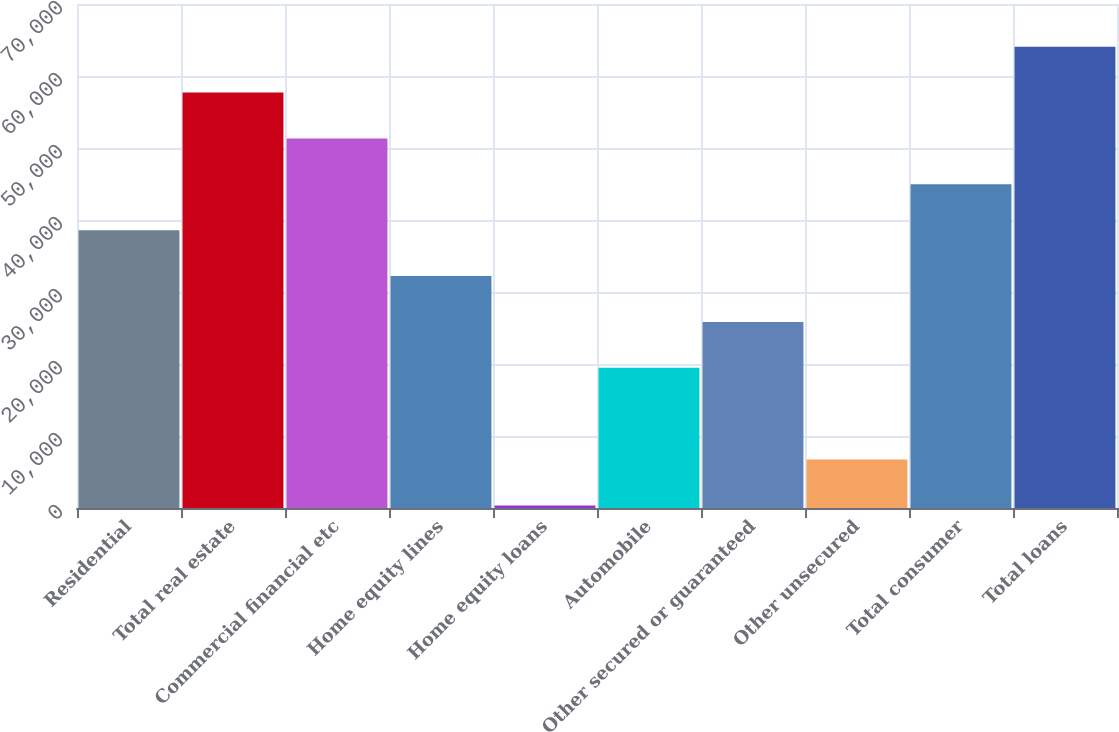<chart> <loc_0><loc_0><loc_500><loc_500><bar_chart><fcel>Residential<fcel>Total real estate<fcel>Commercial financial etc<fcel>Home equity lines<fcel>Home equity loans<fcel>Automobile<fcel>Other secured or guaranteed<fcel>Other unsecured<fcel>Total consumer<fcel>Total loans<nl><fcel>38584.6<fcel>57700.9<fcel>51328.8<fcel>32212.5<fcel>352<fcel>19468.3<fcel>25840.4<fcel>6724.1<fcel>44956.7<fcel>64073<nl></chart> 